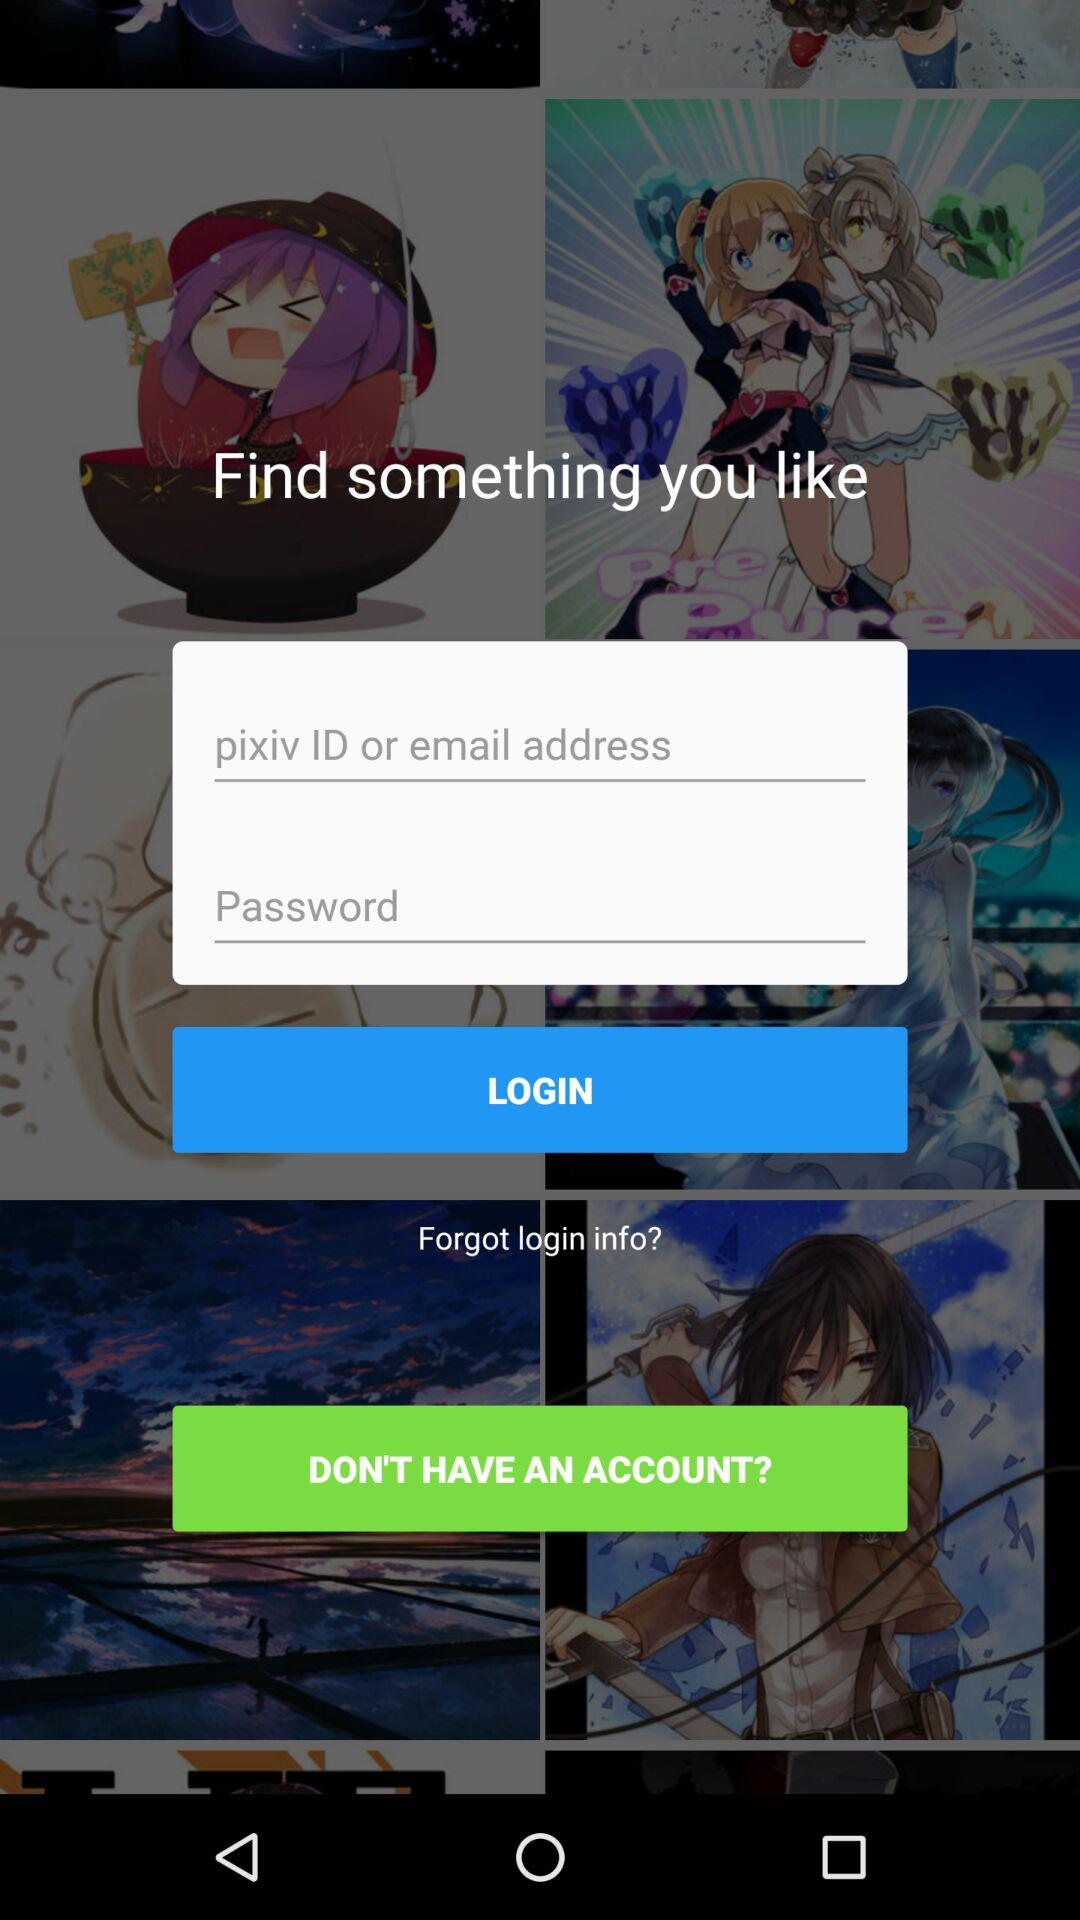How many text fields are in the login screen?
Answer the question using a single word or phrase. 2 